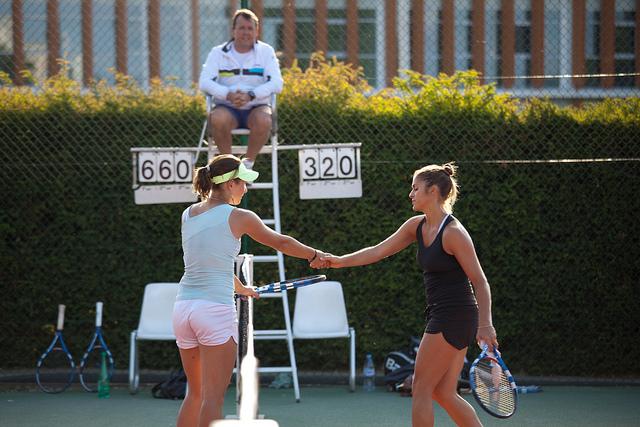What is the woman doing?
Be succinct. Shaking hands. Is the game over?
Give a very brief answer. Yes. What sport are they playing?
Be succinct. Tennis. Are these two women playing against each other?
Concise answer only. Yes. What are the numbers on the right sign?
Write a very short answer. 320. 